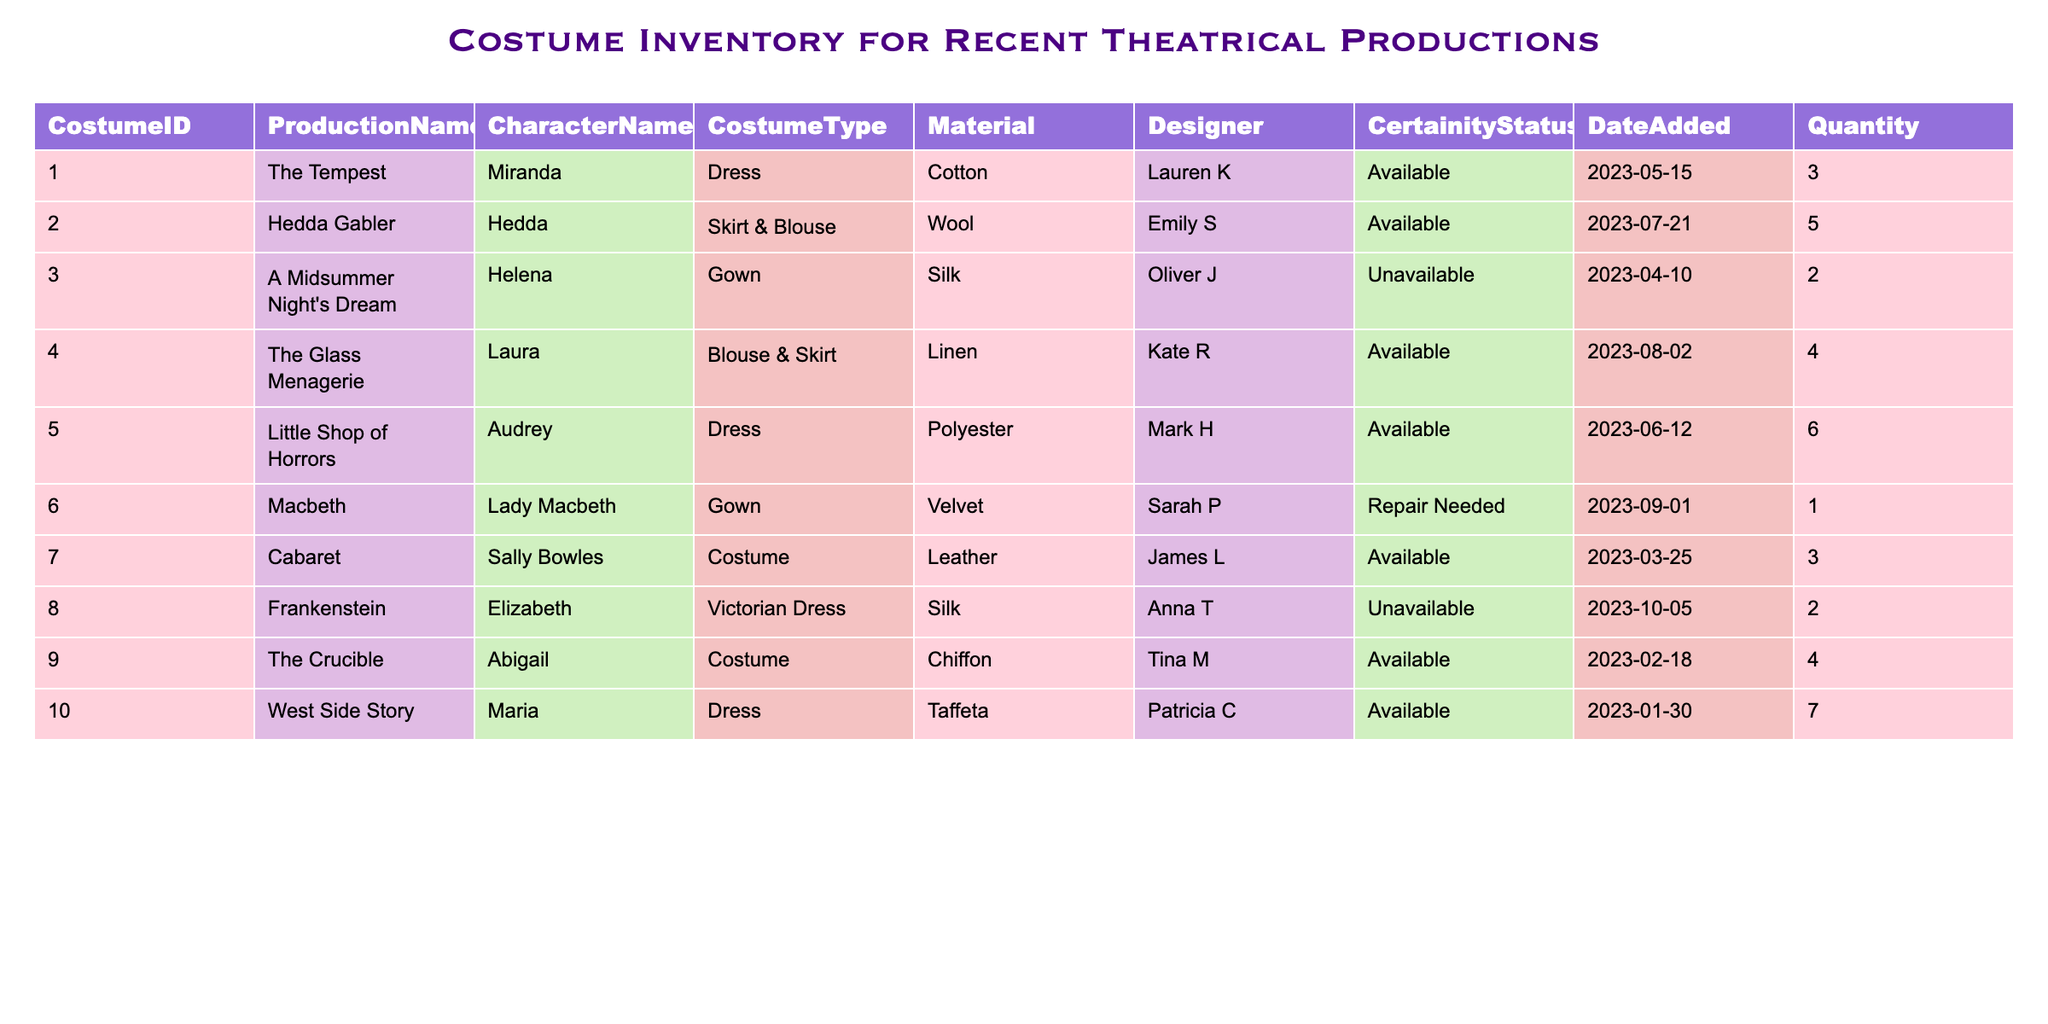What is the costume type for Miranda in The Tempest? According to the table, the costume type for Miranda is listed as "Dress" under the Production Name "The Tempest."
Answer: Dress How many costumes are available for the character Audrey in Little Shop of Horrors? The table indicates that there are 6 costumes available for the character Audrey in the production "Little Shop of Horrors."
Answer: 6 Which production has the highest quantity of costumes available? By examining the quantities listed for each production, "West Side Story" has the highest quantity of costumes available with a total of 7 costumes.
Answer: West Side Story Are there any costumes that need repairs? The table indicates that there is one costume, specifically for Lady Macbeth in "Macbeth," that needs repairs, so the answer is yes.
Answer: Yes What is the total number of available costumes across all productions? By summing the available quantities from the table: 3 (The Tempest) + 5 (Hedda Gabler) + 4 (The Glass Menagerie) + 6 (Little Shop of Horrors) + 3 (Cabaret) + 4 (The Crucible) + 7 (West Side Story) = 32.
Answer: 32 Which materials are being used for costumes in the table? The table lists several materials: Cotton, Wool, Silk, Linen, Polyester, Velvet, Leather, and Chiffon. Each material corresponds to the costumes outlined in the table.
Answer: Cotton, Wool, Silk, Linen, Polyester, Velvet, Leather, Chiffon How many unavailability instances are there in total for costumes? From the table, there are two instances of unavailability: Helena in "A Midsummer Night's Dream" and Elizabeth in "Frankenstein." This adds up to a total of 2 unavailability instances.
Answer: 2 Is there a costume designed by Sarah P that is available? Checking the table, the only costume designed by Sarah P is Lady Macbeth's gown, which is listed as needing repair. Therefore, there is no available costume by Sarah P.
Answer: No What percentage of costumes are currently available out of the total listed? There are 8 costumes listed in total: 5 available, 2 unavailable, and 1 needing repair. The percentage of available costumes is (5 available / 8 total) * 100 = 62.5%.
Answer: 62.5% 